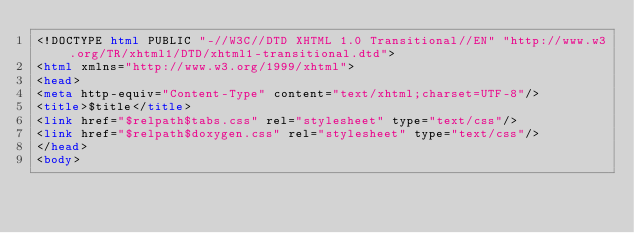<code> <loc_0><loc_0><loc_500><loc_500><_HTML_><!DOCTYPE html PUBLIC "-//W3C//DTD XHTML 1.0 Transitional//EN" "http://www.w3.org/TR/xhtml1/DTD/xhtml1-transitional.dtd">
<html xmlns="http://www.w3.org/1999/xhtml">
<head>
<meta http-equiv="Content-Type" content="text/xhtml;charset=UTF-8"/>
<title>$title</title>
<link href="$relpath$tabs.css" rel="stylesheet" type="text/css"/>
<link href="$relpath$doxygen.css" rel="stylesheet" type="text/css"/>
</head>
<body>
</code> 